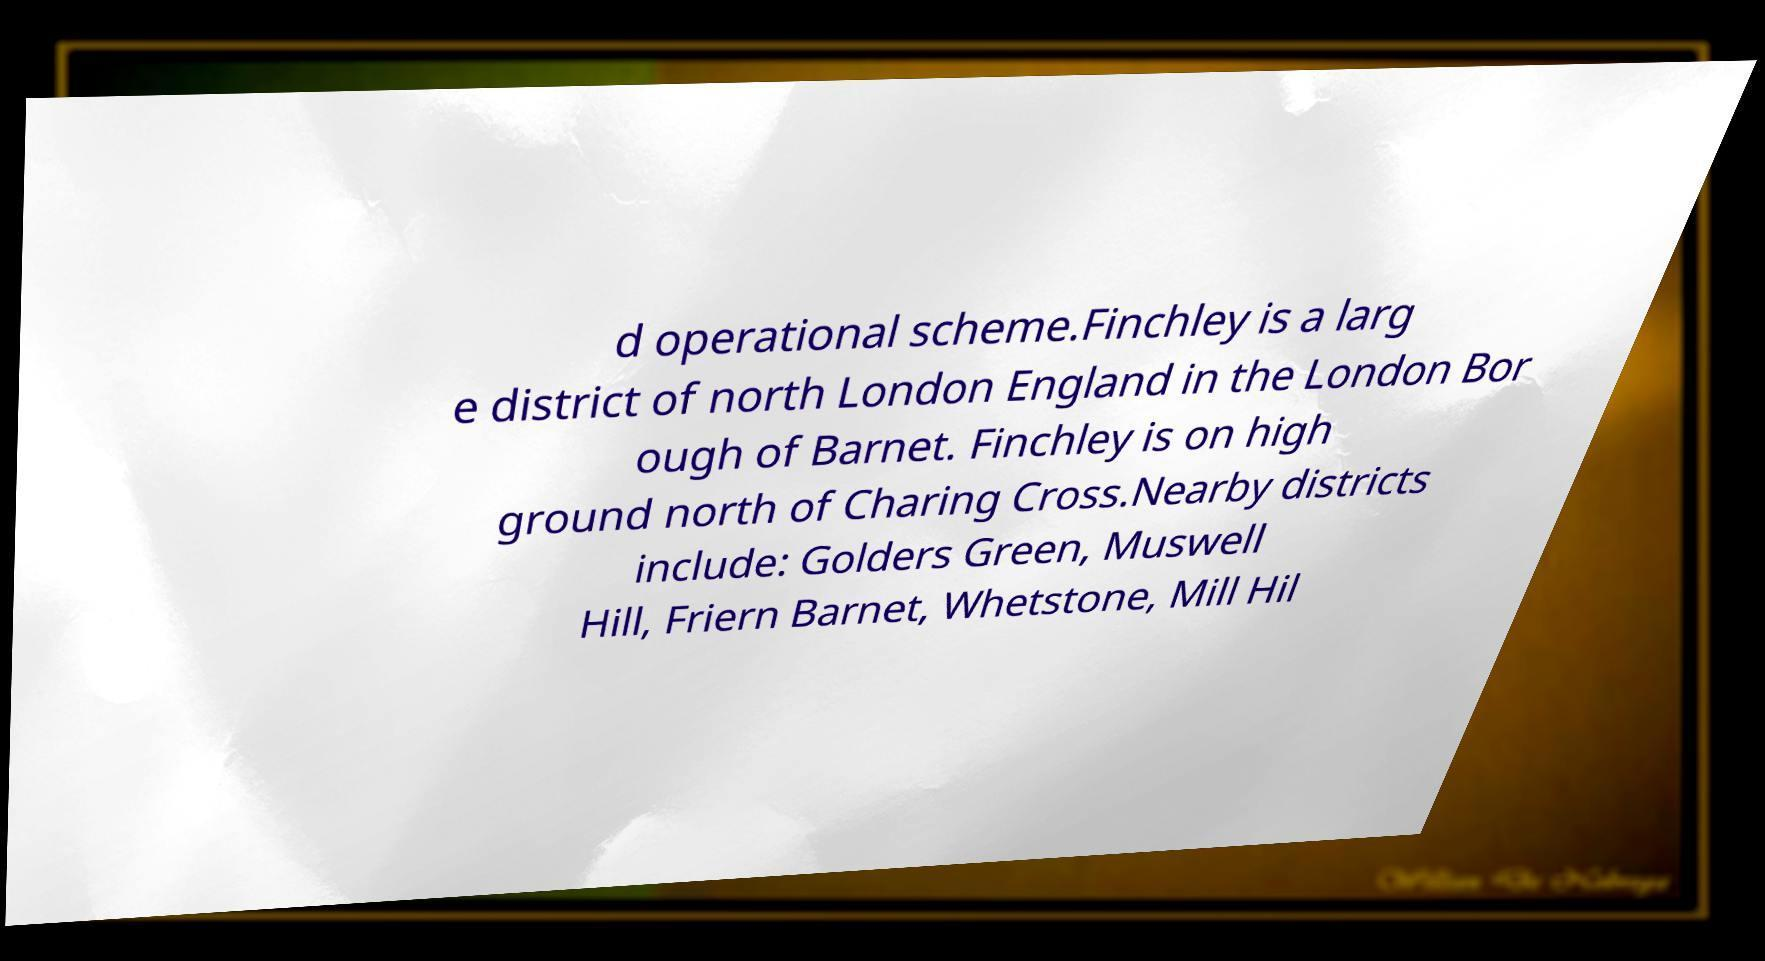Please read and relay the text visible in this image. What does it say? d operational scheme.Finchley is a larg e district of north London England in the London Bor ough of Barnet. Finchley is on high ground north of Charing Cross.Nearby districts include: Golders Green, Muswell Hill, Friern Barnet, Whetstone, Mill Hil 